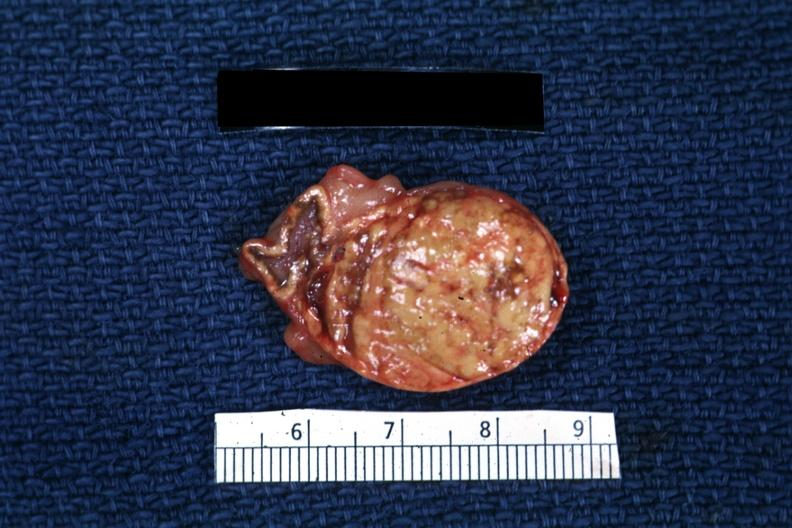where does this belong to?
Answer the question using a single word or phrase. Endocrine system 